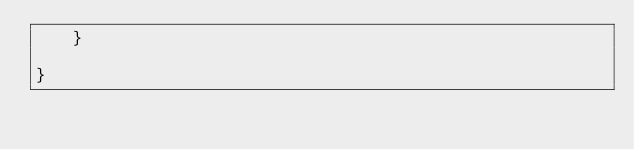Convert code to text. <code><loc_0><loc_0><loc_500><loc_500><_Java_>	}

}
</code> 